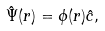Convert formula to latex. <formula><loc_0><loc_0><loc_500><loc_500>\hat { \Psi } ( r ) = \phi ( r ) \hat { c } ,</formula> 